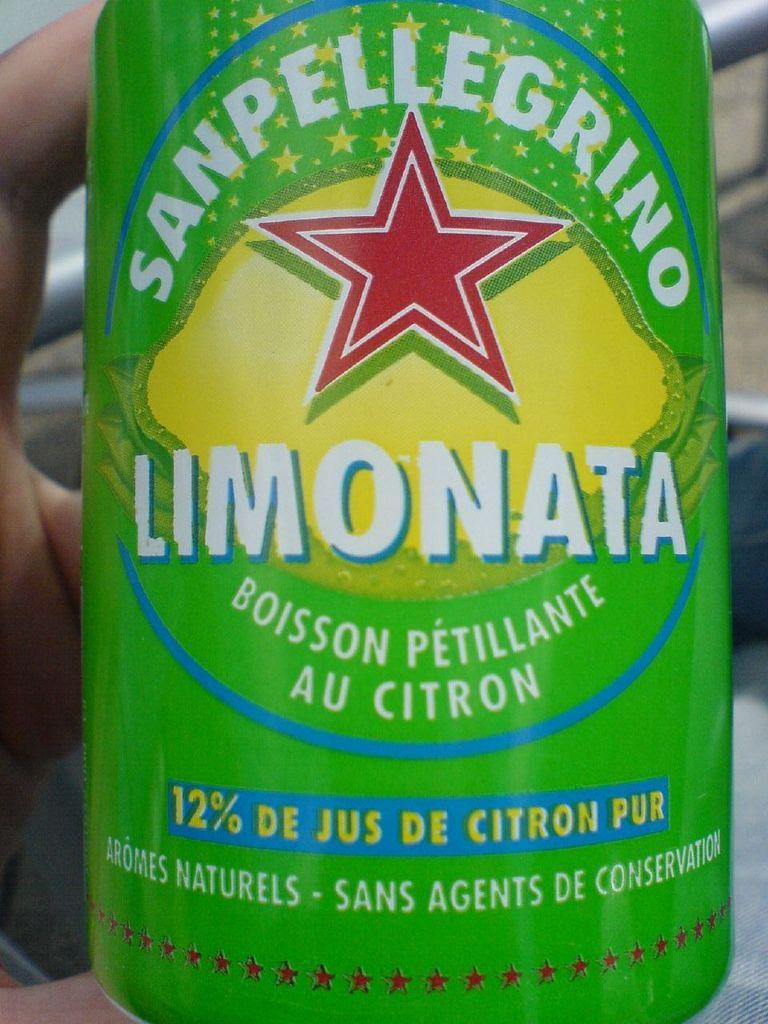<image>
Summarize the visual content of the image. A hand holds a can of Limonata by Sanpelligrino. 